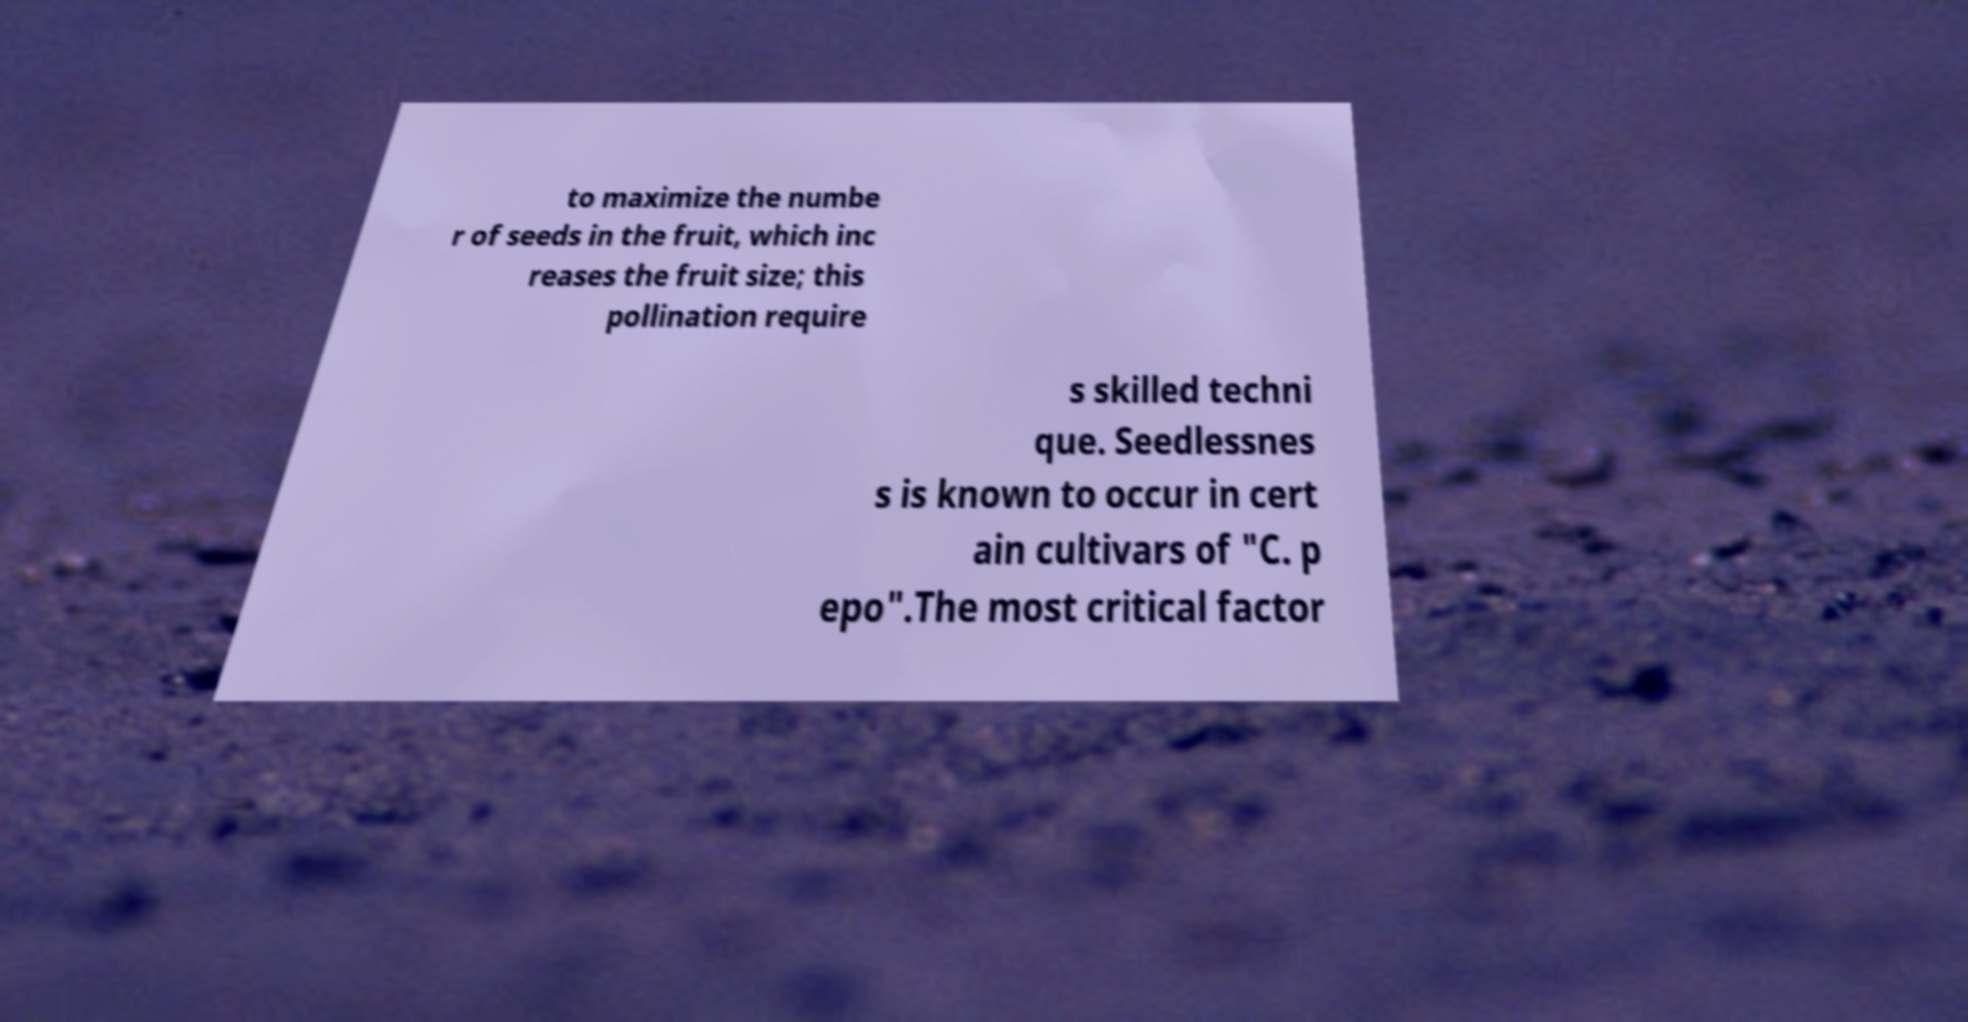There's text embedded in this image that I need extracted. Can you transcribe it verbatim? to maximize the numbe r of seeds in the fruit, which inc reases the fruit size; this pollination require s skilled techni que. Seedlessnes s is known to occur in cert ain cultivars of "C. p epo".The most critical factor 